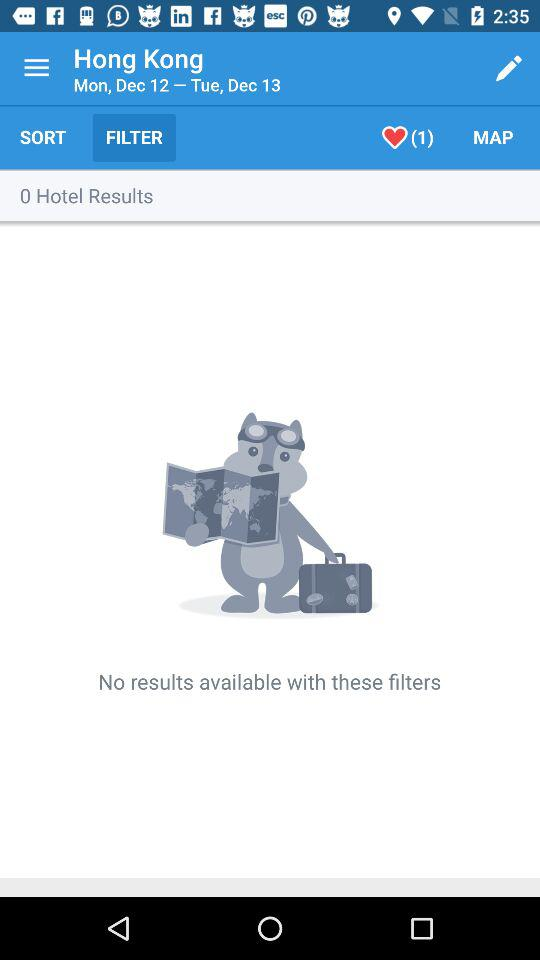What option is selected? The selected option is filter. 